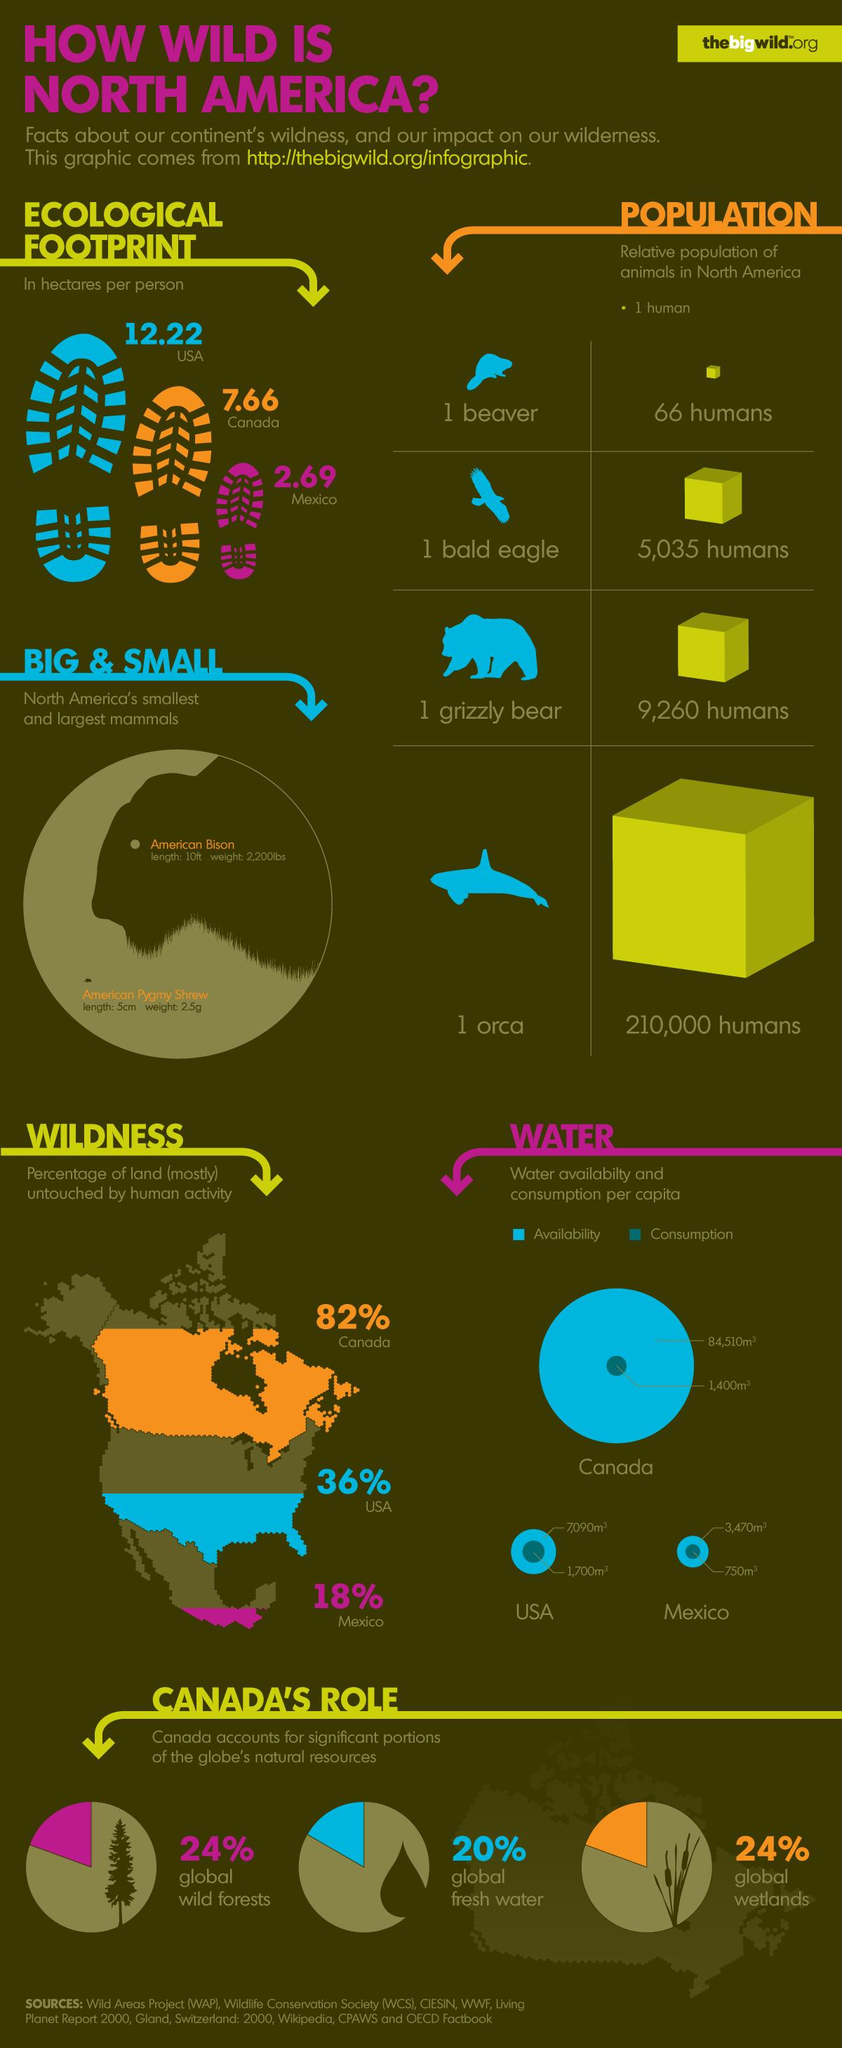Draw attention to some important aspects in this diagram. The water availability per capita in the United States is approximately 7,090 cubic meters. The American Pygmy Shrew is the smallest mammal found in North America. The water availability per capita in Canada is approximately 84,510 cubic meters. The American Bison is the largest mammal found in North America. Canada plays a significant role in the global management and conservation of natural resources, including wild forests, fresh water, and wetlands. 